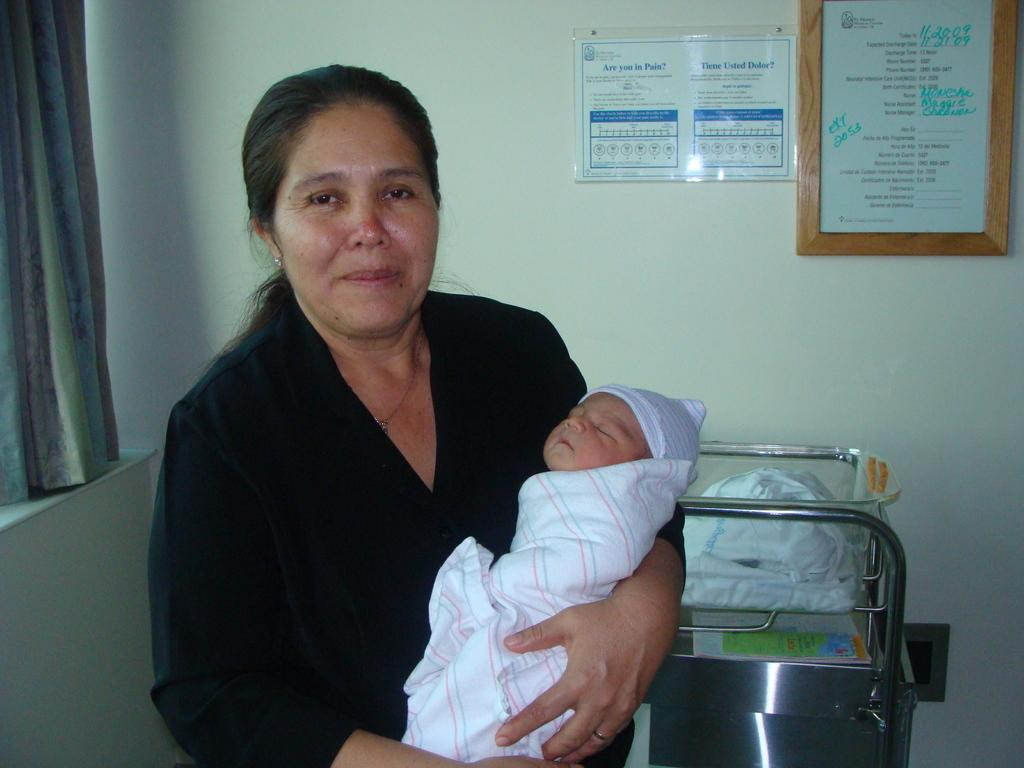<image>
Write a terse but informative summary of the picture. A lady holding a baby in front of a sign that says are you in pain. 